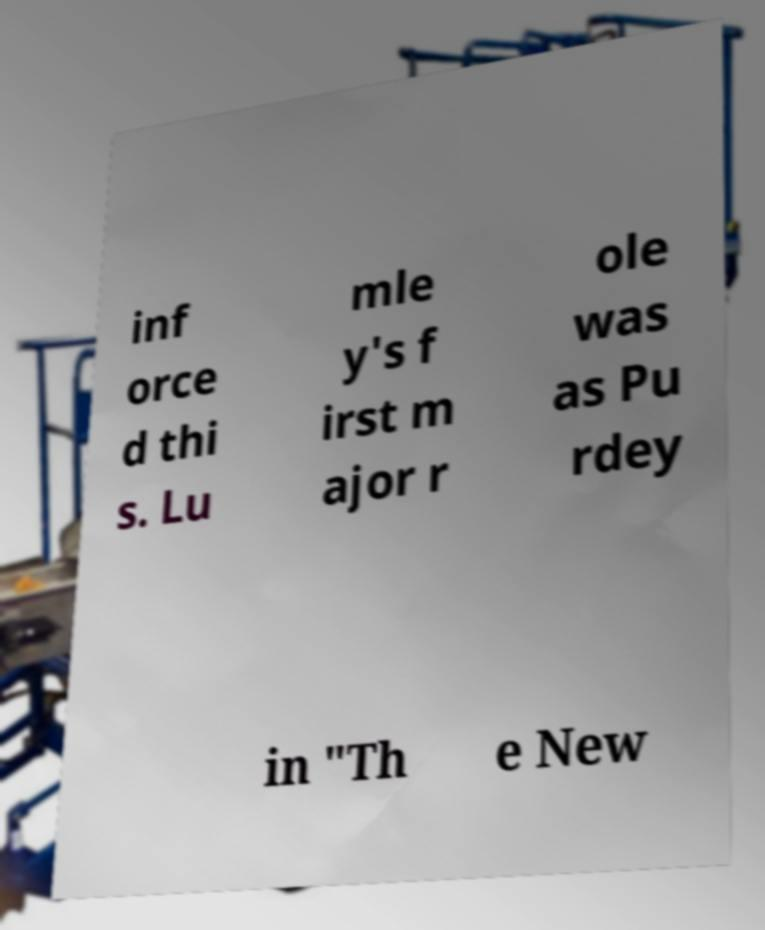For documentation purposes, I need the text within this image transcribed. Could you provide that? inf orce d thi s. Lu mle y's f irst m ajor r ole was as Pu rdey in "Th e New 